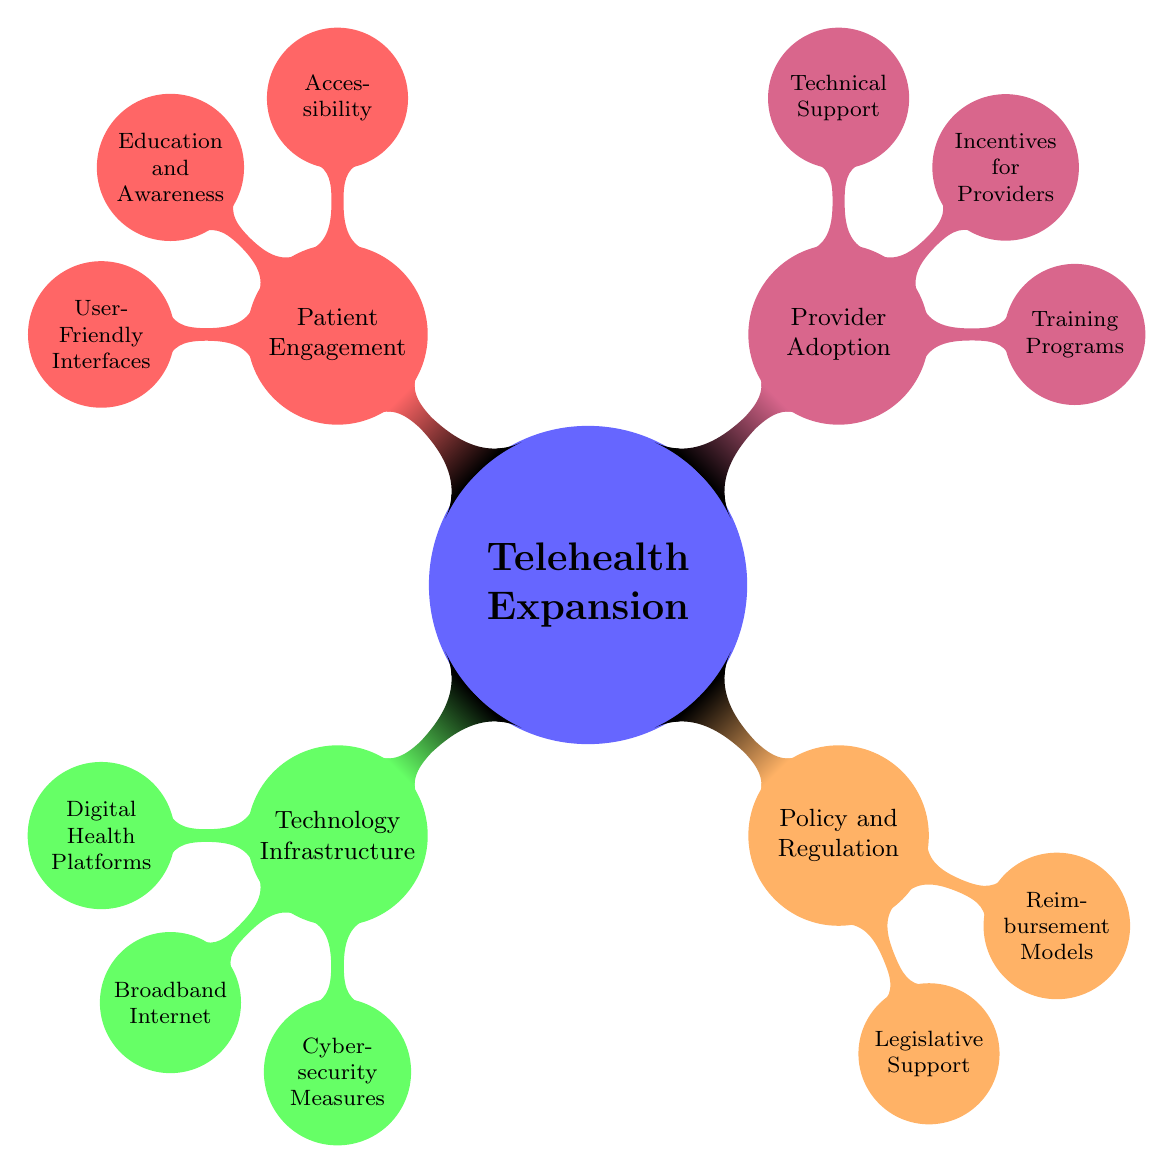What are the main categories represented in the diagram? The diagram categorizes "Telehealth Expansion" into four main groups: "Technology Infrastructure," "Policy and Regulation," "Provider Adoption," and "Patient Engagement."
Answer: Technology Infrastructure, Policy and Regulation, Provider Adoption, Patient Engagement How many nodes are under "Provider Adoption"? Under "Provider Adoption," there are three nodes: "Training Programs," "Incentives for Providers," and "Technical Support."
Answer: 3 What are the specific reimbursement models mentioned in the diagram? The reimbursement models listed under "Policy and Regulation" are "Medicare Telehealth Reimbursement" and "Private Insurance Coverage."
Answer: Medicare Telehealth Reimbursement, Private Insurance Coverage Which category includes "5G Network Implementation"? "5G Network Implementation" is a part of the "Broadband Internet" node, which falls under the "Technology Infrastructure" category.
Answer: Technology Infrastructure How does "Patient Engagement" support "Telehealth Expansion"? "Patient Engagement" helps expand telehealth by enhancing "Accessibility," fostering "Education and Awareness," and providing "User-Friendly Interfaces," all of which encourage patient participation in telehealth services.
Answer: Accessibility, Education and Awareness, User-Friendly Interfaces What are the cybersecurity measures listed? The diagram specifies two cybersecurity measures: "HIPAA Compliance" and "Encrypted Communications" under "Cybersecurity Measures."
Answer: HIPAA Compliance, Encrypted Communications Which node has the highest number of children nodes? "Technology Infrastructure" has the highest number of children nodes with three: "Digital Health Platforms," "Broadband Internet," and "Cybersecurity Measures."
Answer: Technology Infrastructure What legislative support is noted in the diagram? The legislative support mentioned includes "Telehealth Expansion Act" and "CARES Act Provisions," which are under the "Policy and Regulation" category.
Answer: Telehealth Expansion Act, CARES Act Provisions 